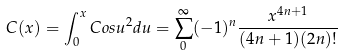Convert formula to latex. <formula><loc_0><loc_0><loc_500><loc_500>C ( x ) = \int _ { 0 } ^ { x } C o s u ^ { 2 } d u = \sum _ { 0 } ^ { \infty } ( - 1 ) ^ { n } \frac { x ^ { 4 n + 1 } } { ( 4 n + 1 ) ( 2 n ) ! }</formula> 